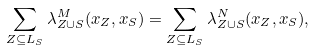<formula> <loc_0><loc_0><loc_500><loc_500>\sum _ { Z \subseteq L _ { S } } \lambda _ { Z \cup S } ^ { M } ( x _ { Z } , x _ { S } ) = \sum _ { Z \subseteq L _ { S } } \lambda _ { Z \cup S } ^ { N } ( x _ { Z } , x _ { S } ) ,</formula> 